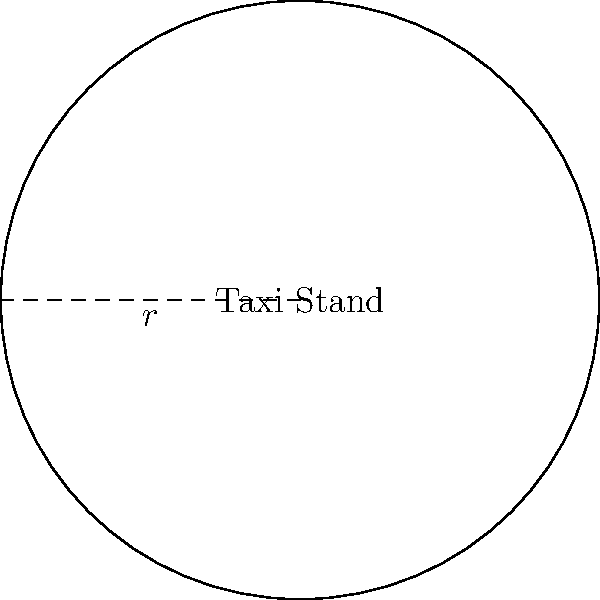As you deliver mail to the local taxi stand, you notice its circular shape. The radius of the stand is 15 meters. What is the total area of the taxi stand? To find the area of the circular taxi stand, we need to use the formula for the area of a circle:

1. The formula for the area of a circle is $A = \pi r^2$, where $A$ is the area and $r$ is the radius.

2. We are given that the radius is 15 meters.

3. Let's substitute the values into the formula:
   $A = \pi (15)^2$

4. Simplify the expression inside the parentheses:
   $A = \pi (225)$

5. Multiply:
   $A = 706.86$ square meters (rounded to two decimal places)

As a postman who appreciates precision, it's important to note that this calculation gives us the exact area of the taxi stand, which could be useful for understanding the space allocation in the neighborhood.
Answer: $706.86$ m² 